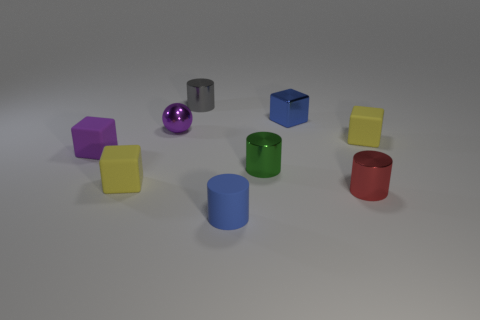Are there the same number of green objects that are in front of the tiny red cylinder and tiny yellow blocks?
Provide a succinct answer. No. There is a yellow object to the right of the blue rubber thing; is it the same size as the metal cylinder behind the blue block?
Provide a short and direct response. Yes. What number of other objects are there of the same size as the matte cylinder?
Keep it short and to the point. 8. Is there a small red cylinder behind the small block that is behind the tiny yellow matte thing to the right of the tiny metallic sphere?
Provide a short and direct response. No. Are there any other things that have the same color as the ball?
Offer a terse response. Yes. What is the size of the yellow thing right of the gray cylinder?
Provide a short and direct response. Small. What is the size of the gray cylinder behind the blue thing that is behind the small matte cube that is right of the tiny green metallic thing?
Keep it short and to the point. Small. What is the color of the rubber object that is on the left side of the tiny yellow object left of the matte cylinder?
Provide a short and direct response. Purple. There is a tiny green thing that is the same shape as the tiny red thing; what is it made of?
Offer a very short reply. Metal. Is there any other thing that has the same material as the tiny green cylinder?
Your response must be concise. Yes. 